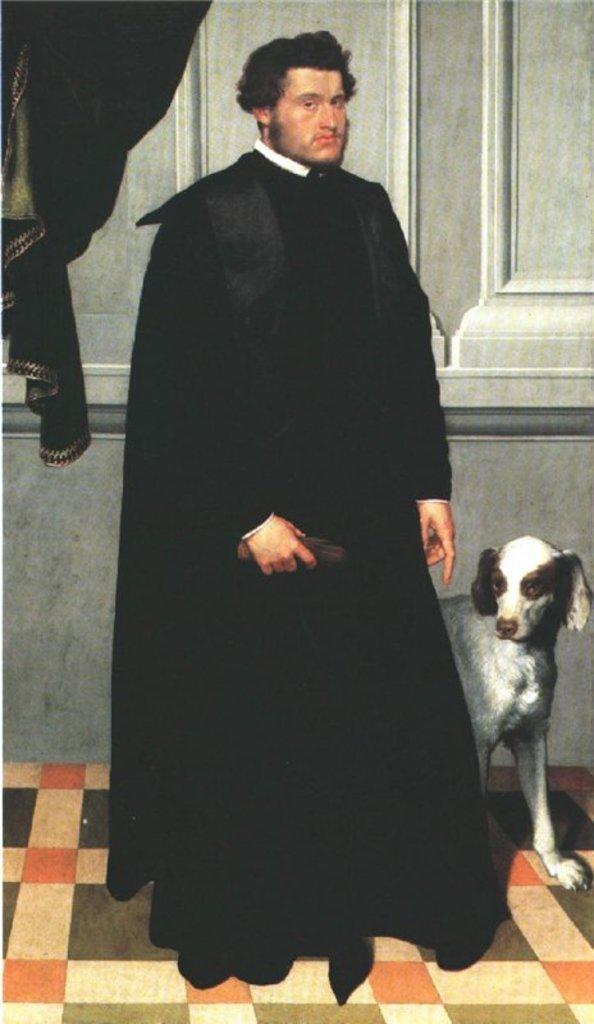Could you give a brief overview of what you see in this image? In this picture there is a black curtain in the left corner. There is a person with a black dress and a dog in the foreground. There is mat at the bottom. And the wall is at the background. 